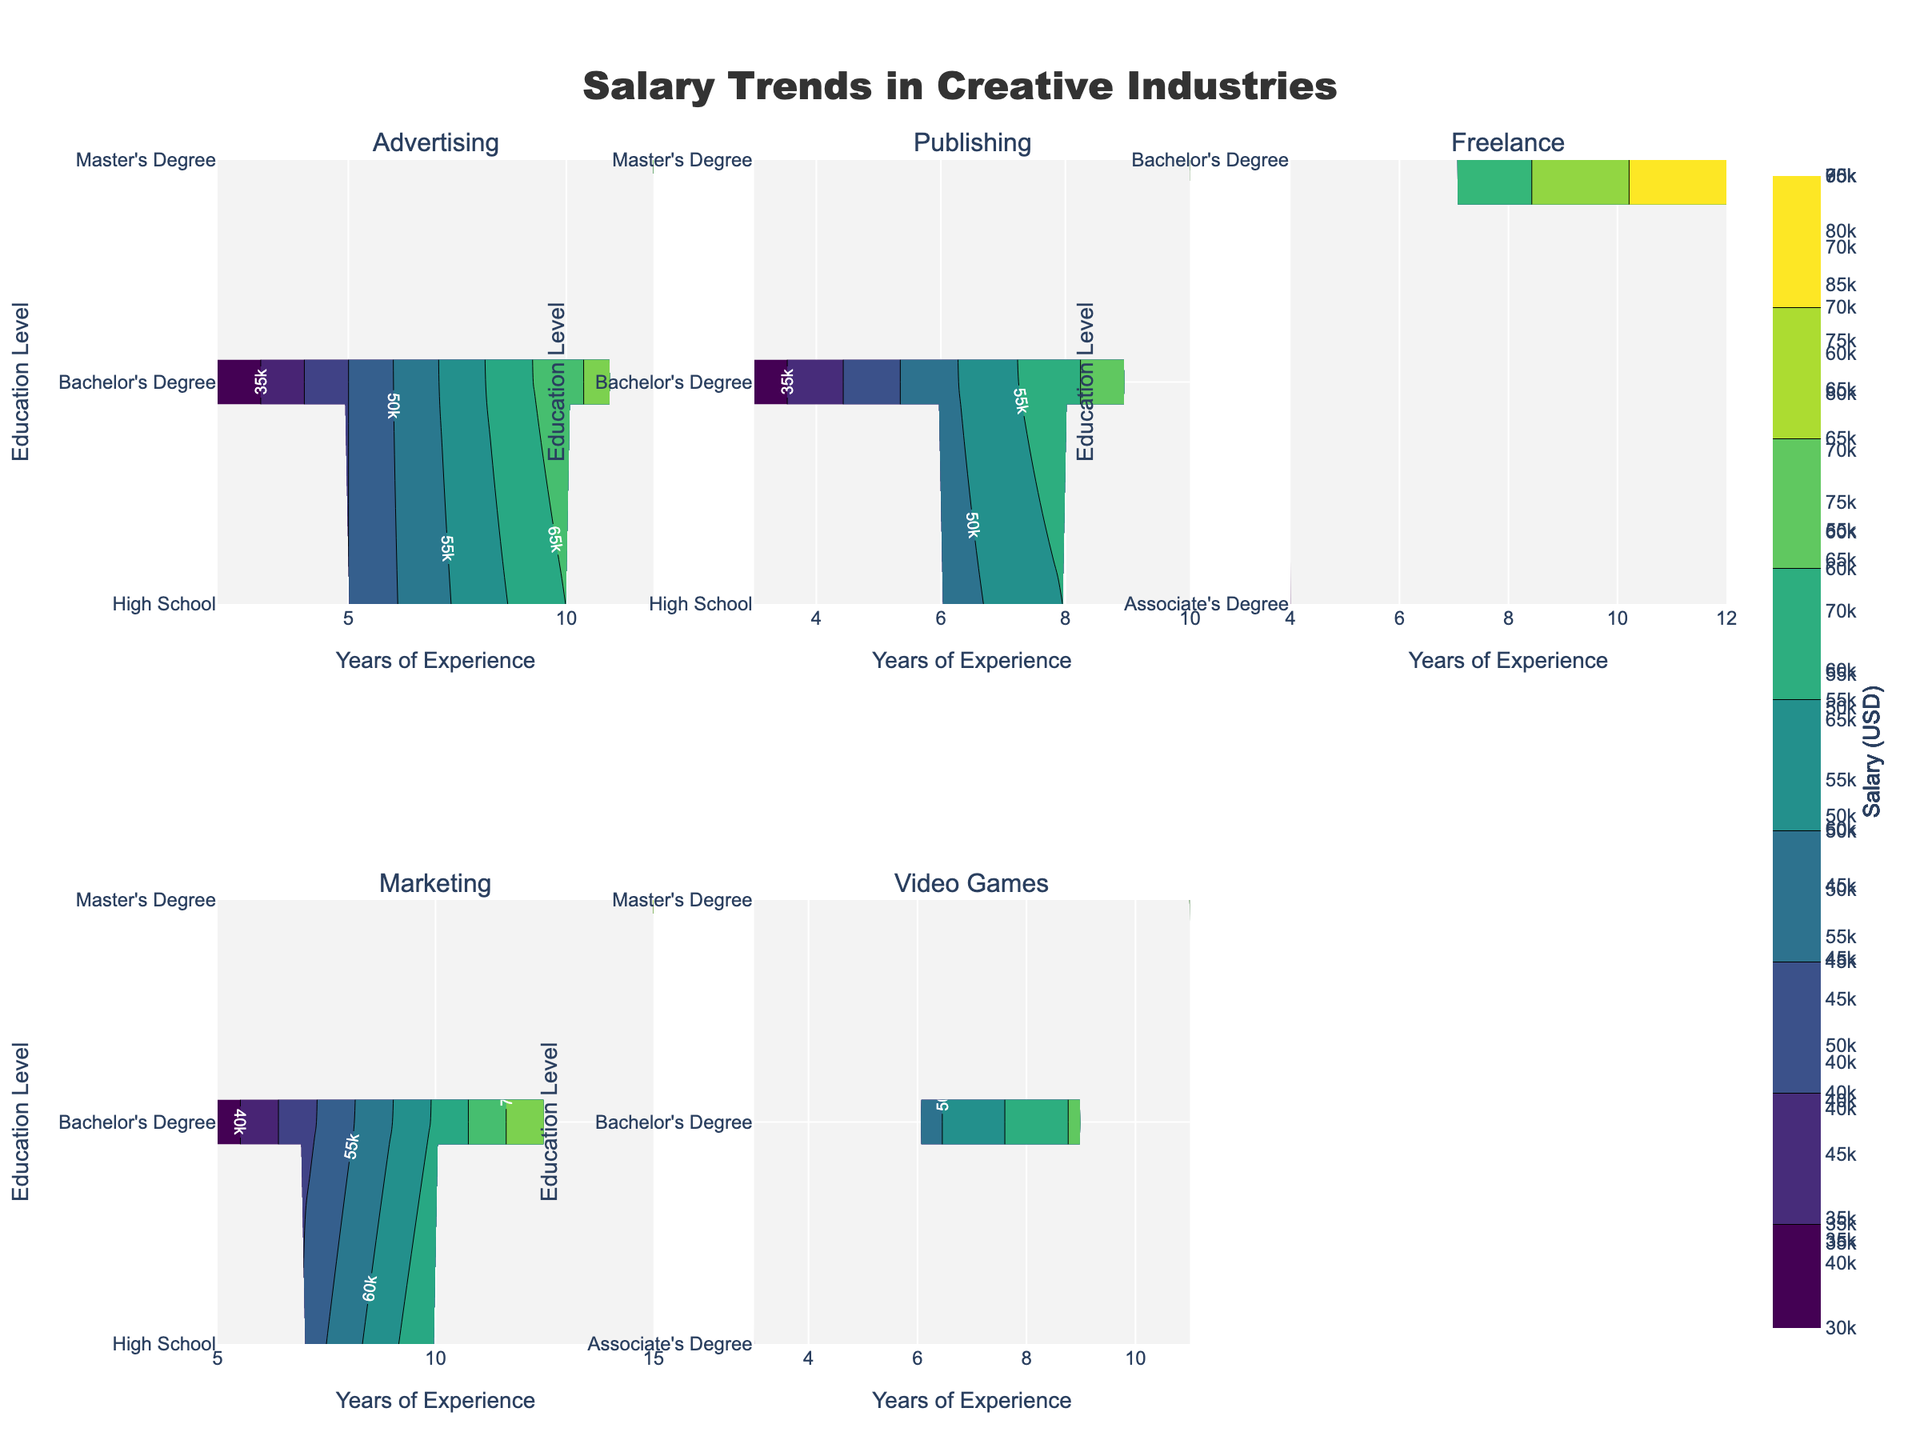What's the overall title of the figure? The overall title of the figure is displayed prominently at the top and is related to the theme, so the reader can immediately understand what the figure is about.
Answer: Salary Trends in Creative Industries How many subplots are in the figure, and what does each subplot represent? The figure has six subplots, each representing a different industry. Identify the count of plots and their respective titles, such as "Advertising," "Publishing," "Freelance," "Marketing," and "Video Games."
Answer: Six; Advertising, Publishing, Freelance, Marketing, Video Games What does the color bar on the right side of each subplot in the figure represent? The color bar indicates the range of salary levels in USD for creative professionals within each industry. Colors reflect different salary ranges.
Answer: Salary (USD) In which subplot do creative professionals with the most experience earn the highest salaries, and what is the approximate range? Examine the top salary contours in each subplot and find the one with the highest salary values. The subplot for Marketing shows the highest salaries, approximately in the range of $90,000.
Answer: Marketing; $90,000 How do the salary trends for professionals with a Bachelor's Degree vary across different industries? Look at the contours associated with Bachelor's Degree category in each subplot. Compare rather than compute the absolute numbers. Trends show increasing salaries with experience, but the peak levels and slopes differ by industry.
Answer: Differently; Rising with experience What is the Educational Level for professionals with around 10 years of experience that exhibit the highest salary in the Video Games industry? Trace the contour lines around the 10-year mark in the Video Games subplot to locate which educational level corresponds to higher salaries. The highest salary around this point is associated with a Master’s Degree.
Answer: Master's Degree Which industry shows the least variation in salary levels for creative professionals with different years of experience and education levels? Evaluate the spread and smoothness of contour lines across all subplots. The Advertising subplot shows relatively fewer variations in salary levels across different experience and education levels.
Answer: Advertising Which industry has the highest overall initial salary for professionals with High School education? Look at the starting salaries in the "High School" category in each subplot. Identify which industry's subplot starts higher. Freelance shows the highest initial salary for High School education.
Answer: Freelance How do salaries progress for professionals with a Master's Degree compared to those with a Bachelor's Degree, across the different industries? Compare contour heights for Master’s Degree and Bachelor’s Degree in all subplots. Salaries for professionals with a Master’s Degree generally progress more steeply and reach higher levels than those with a Bachelor’s Degree.
Answer: Steeper and higher for Master’s Degree 